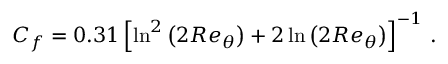<formula> <loc_0><loc_0><loc_500><loc_500>C _ { f } = 0 . 3 1 \left [ \ln ^ { 2 } { \left ( 2 R e _ { \theta } \right ) } + 2 \ln { \left ( 2 R e _ { \theta } \right ) } \right ] ^ { - 1 } \, .</formula> 